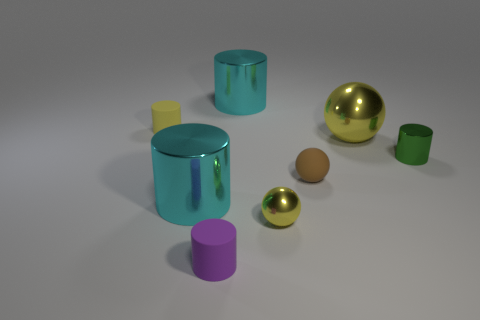Subtract 1 cylinders. How many cylinders are left? 4 Subtract all tiny purple cylinders. How many cylinders are left? 4 Subtract all blue cylinders. Subtract all cyan balls. How many cylinders are left? 5 Add 2 big yellow spheres. How many objects exist? 10 Subtract all balls. How many objects are left? 5 Subtract 0 purple spheres. How many objects are left? 8 Subtract all yellow shiny objects. Subtract all purple rubber cylinders. How many objects are left? 5 Add 1 small spheres. How many small spheres are left? 3 Add 1 small brown shiny things. How many small brown shiny things exist? 1 